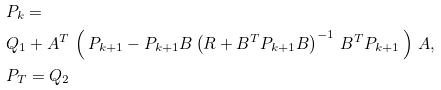Convert formula to latex. <formula><loc_0><loc_0><loc_500><loc_500>& P _ { k } = \\ & Q _ { 1 } + A ^ { T } \, \left ( \, P _ { k + 1 } - P _ { k + 1 } B \left ( R + B ^ { T } P _ { k + 1 } B \right ) ^ { - 1 } \, B ^ { T } P _ { k + 1 } \, \right ) \, A , \\ & P _ { T } = Q _ { 2 }</formula> 